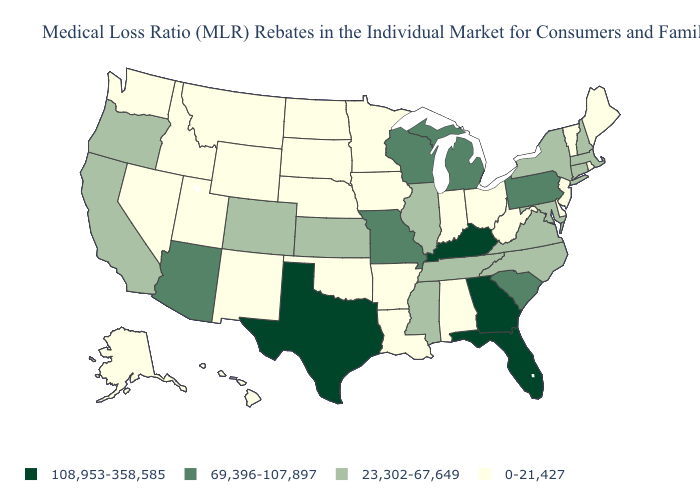What is the value of Kentucky?
Be succinct. 108,953-358,585. Does the map have missing data?
Concise answer only. No. What is the value of Vermont?
Concise answer only. 0-21,427. Among the states that border Indiana , which have the highest value?
Answer briefly. Kentucky. What is the highest value in the MidWest ?
Short answer required. 69,396-107,897. Does New York have a lower value than Wisconsin?
Quick response, please. Yes. Among the states that border Iowa , does Minnesota have the lowest value?
Concise answer only. Yes. Which states have the lowest value in the USA?
Write a very short answer. Alabama, Alaska, Arkansas, Delaware, Hawaii, Idaho, Indiana, Iowa, Louisiana, Maine, Minnesota, Montana, Nebraska, Nevada, New Jersey, New Mexico, North Dakota, Ohio, Oklahoma, Rhode Island, South Dakota, Utah, Vermont, Washington, West Virginia, Wyoming. Name the states that have a value in the range 0-21,427?
Quick response, please. Alabama, Alaska, Arkansas, Delaware, Hawaii, Idaho, Indiana, Iowa, Louisiana, Maine, Minnesota, Montana, Nebraska, Nevada, New Jersey, New Mexico, North Dakota, Ohio, Oklahoma, Rhode Island, South Dakota, Utah, Vermont, Washington, West Virginia, Wyoming. Name the states that have a value in the range 69,396-107,897?
Short answer required. Arizona, Michigan, Missouri, Pennsylvania, South Carolina, Wisconsin. What is the value of North Carolina?
Keep it brief. 23,302-67,649. Which states hav the highest value in the MidWest?
Short answer required. Michigan, Missouri, Wisconsin. What is the highest value in the South ?
Be succinct. 108,953-358,585. Name the states that have a value in the range 23,302-67,649?
Write a very short answer. California, Colorado, Connecticut, Illinois, Kansas, Maryland, Massachusetts, Mississippi, New Hampshire, New York, North Carolina, Oregon, Tennessee, Virginia. 